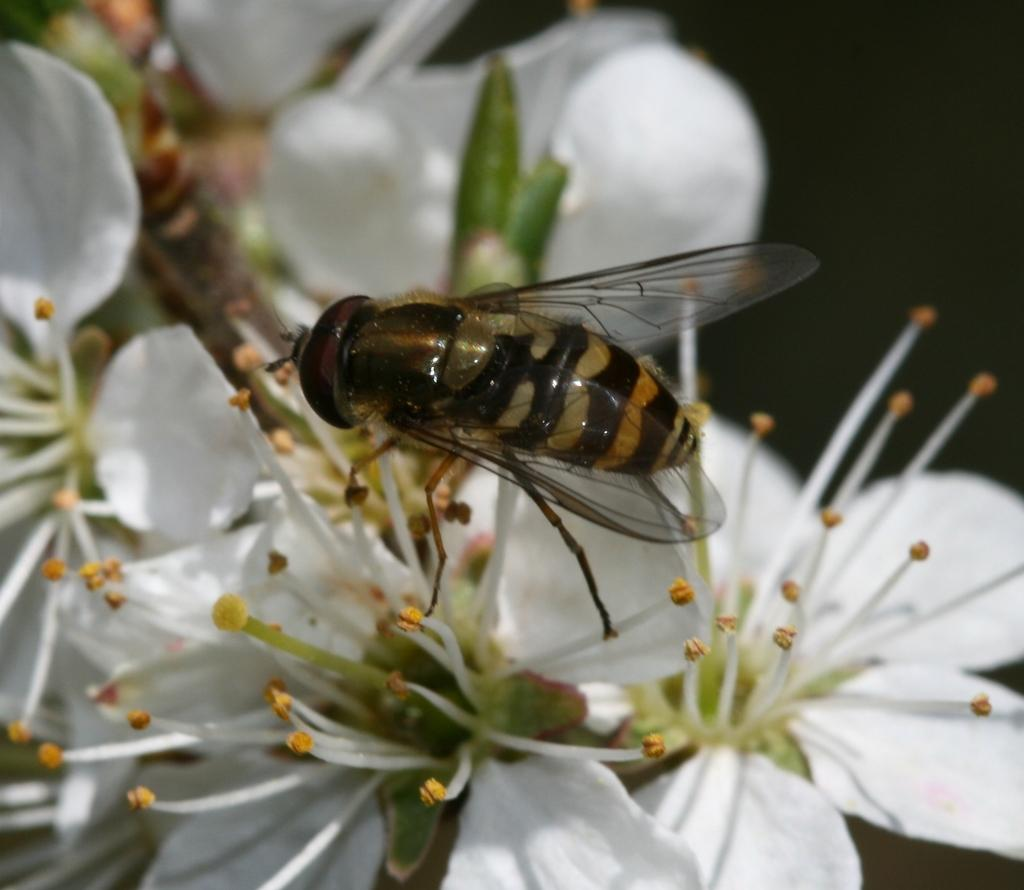What is the main subject in the center of the image? There are flowers in the center of the image. What color are the flowers? The flowers are white in color. Is there anything else present on the flowers? Yes, there is an insect on one of the flowers. What color is the insect? The insect is black in color. What historical event is being celebrated in the image? There is no indication of a historical event or celebration in the image; it features flowers and an insect. How many fangs does the insect have in the image? There is no insect with fangs present in the image; the insect is black and on a white flower. 